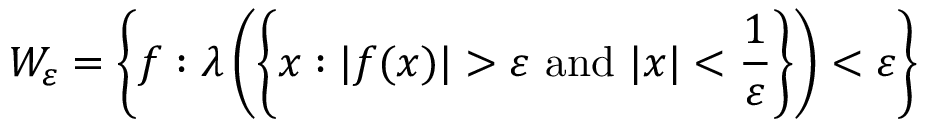Convert formula to latex. <formula><loc_0><loc_0><loc_500><loc_500>W _ { \varepsilon } = \left \{ f \colon \lambda \left ( \left \{ x \colon | f ( x ) | > \varepsilon { a n d } | x | < { \frac { 1 } { \varepsilon } } \right \} \right ) < \varepsilon \right \}</formula> 